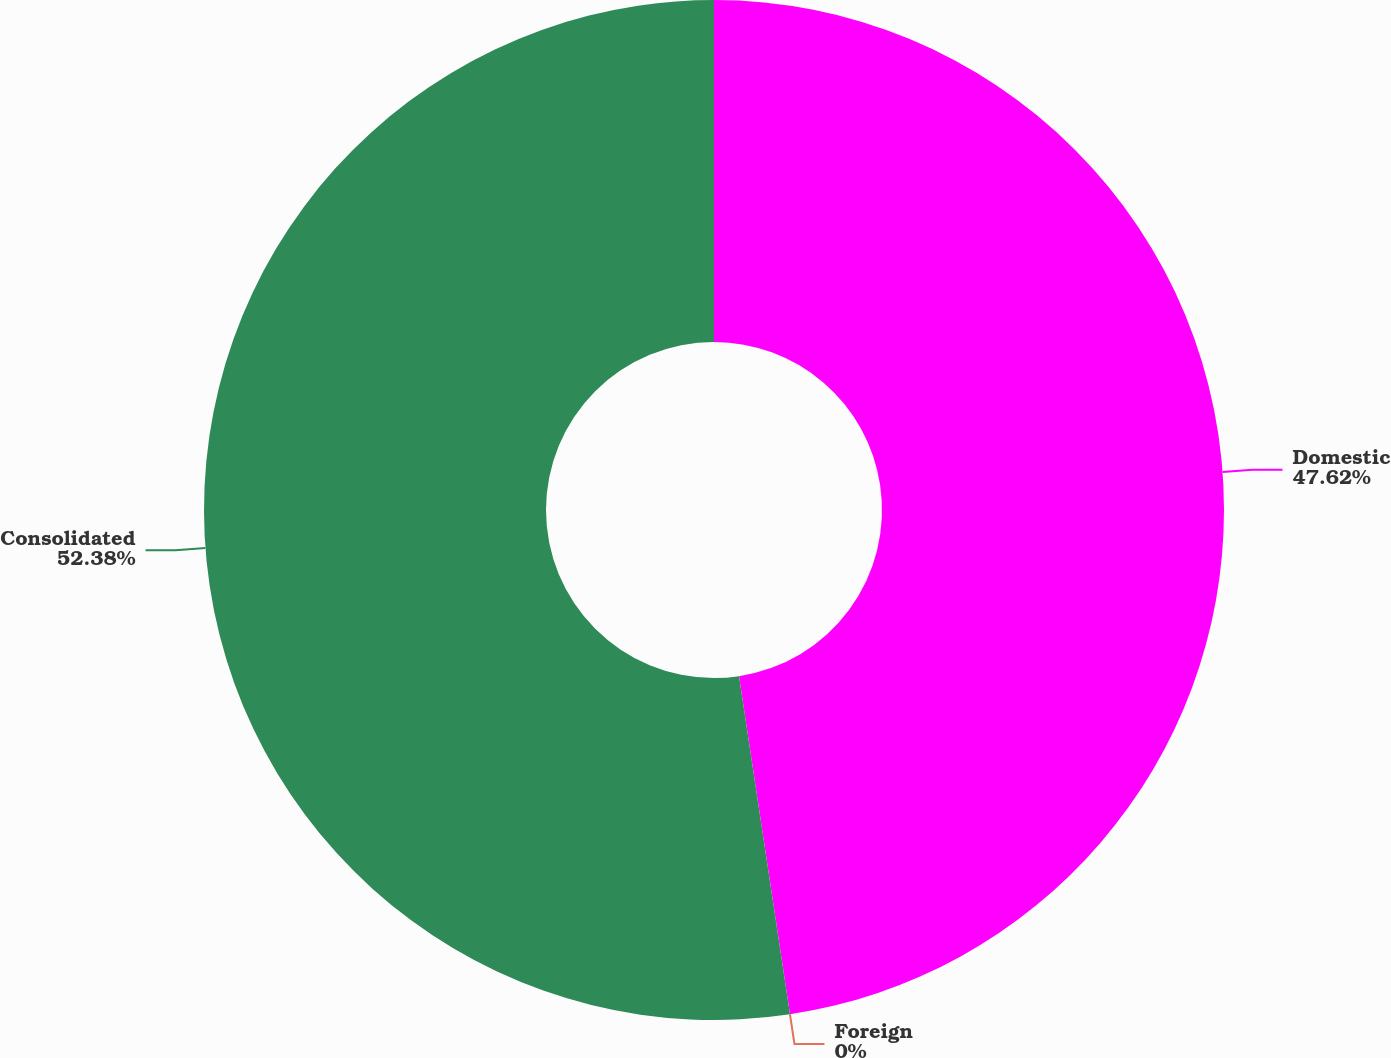<chart> <loc_0><loc_0><loc_500><loc_500><pie_chart><fcel>Domestic<fcel>Foreign<fcel>Consolidated<nl><fcel>47.62%<fcel>0.0%<fcel>52.38%<nl></chart> 